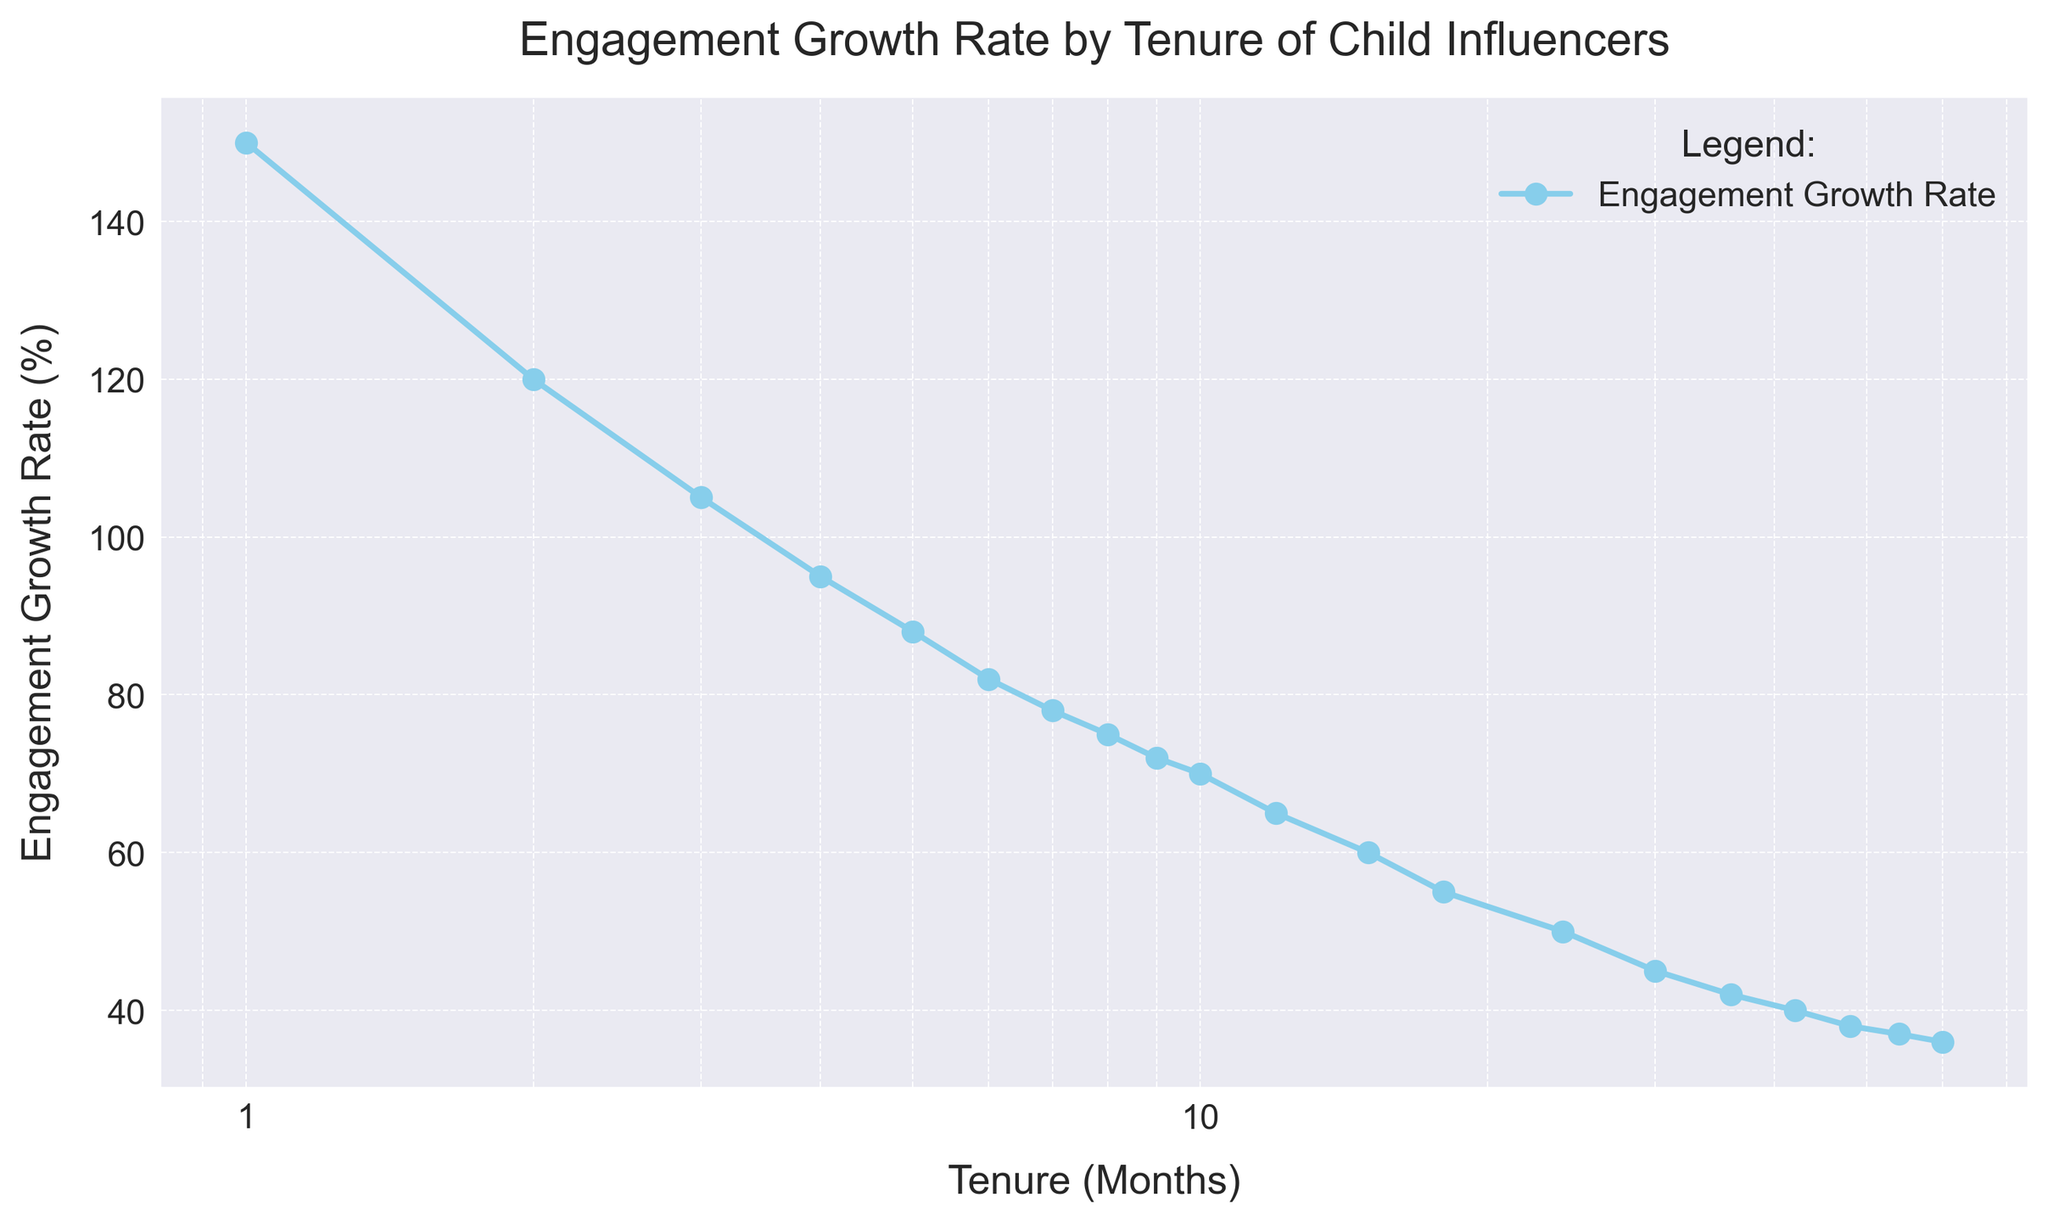What is the Engagement Growth Rate at a Tenure of 12 months? Refer to the point on the scatter plot that corresponds to a Tenure of 12 months and read its y-axis value. The Engagement Growth Rate at this point is 65%.
Answer: 65% How much does the Engagement Growth Rate decrease from a Tenure of 1 month to 2 months? Identify the Engagement Growth Rate at 1 month (150%) and 2 months (120%), then calculate the decrease by subtracting the latter from the former: 150% - 120% = 30%.
Answer: 30% What is the difference in Engagement Growth Rate between Tenure of 30 months and 60 months? Locate the Engagement Growth Rates for 30 months (45%) and 60 months (36%). Subtract the Engagement Growth Rate at 60 months from that at 30 months: 45% - 36% = 9%.
Answer: 9% Which Tenure month shows the highest Engagement Growth Rate? Inspect the y-values for each point on the scatter plot and determine the highest value, which corresponds to a Tenure of 1 month with an Engagement Growth Rate of 150%.
Answer: 1 month How does the Engagement Growth Rate trend as Tenure increases from 1 month to 24 months? Observe the scatter plot's general trend: as Tenure increases from 1 month to 24 months, the Engagement Growth Rate steadily decreases from 150% to 50%, indicating a negative trend.
Answer: Negative trend What is the ratio of Engagement Growth Rate at 3 months to that at 36 months? Find the Engagement Growth Rates at 3 months (105%) and 36 months (42%), and then compute the ratio: 105 / 42 ≈ 2.5.
Answer: 2.5 Between which two consecutive Tenure months is the smallest drop in Engagement Growth Rate observed? Check the differences in Engagement Growth Rates between each pair of consecutive tenures; the smallest drop occurs between 54 months (37%) and 60 months (36%), with a difference of 1%.
Answer: Between 54 and 60 months How much did the Engagement Growth Rate decrease from a Tenure of 10 months to 12 months? Identify the Engagement Growth Rates at 10 months (70%) and 12 months (65%), and compute the difference: 70% - 65% = 5%.
Answer: 5% How does the Engagement Growth Rate change after 24 months compared to before? Compare the trend before and after 24 months: before 24 months, the Engagement Growth Rate drops sharply, while after 24 months, it continues to decrease but at a slower rate.
Answer: Decrease slows What is the average Engagement Growth Rate for Tenure values 1, 12, and 60 months? Add the Engagement Growth Rates for 1 month (150%), 12 months (65%), and 60 months (36%) and then divide by 3: (150 + 65 + 36) / 3 = 84%.
Answer: 84% 